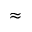<formula> <loc_0><loc_0><loc_500><loc_500>\approx</formula> 